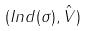<formula> <loc_0><loc_0><loc_500><loc_500>( I n d ( \sigma ) , \hat { V } )</formula> 